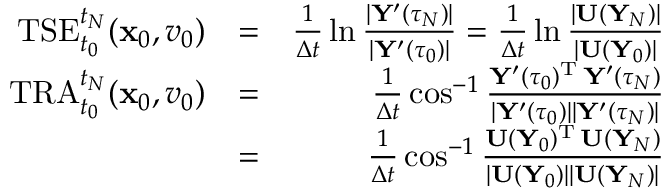<formula> <loc_0><loc_0><loc_500><loc_500>\begin{array} { r l r } { T S E _ { t _ { 0 } } ^ { t _ { N } } ( { \mathbf x } _ { 0 } , v _ { 0 } ) } & { = } & { \frac { 1 } { \Delta t } \ln \frac { | { \mathbf Y } ^ { \prime } ( \tau _ { N } ) | } { | { \mathbf Y } ^ { \prime } ( \tau _ { 0 } ) | } = \frac { 1 } { \Delta t } \ln \frac { | { \mathbf U } ( { \mathbf Y } _ { N } ) | } { | { \mathbf U } ( { \mathbf Y } _ { 0 } ) | } } \\ { T R A _ { t _ { 0 } } ^ { t _ { N } } ( { \mathbf x } _ { 0 } , v _ { 0 } ) } & { = } & { \frac { 1 } { \Delta t } \cos ^ { - 1 } \frac { { \mathbf Y } ^ { \prime } ( \tau _ { 0 } ) ^ { \mathrm T } \, { \mathbf Y } ^ { \prime } ( \tau _ { N } ) } { | { \mathbf Y } ^ { \prime } ( \tau _ { 0 } ) | | { \mathbf Y } ^ { \prime } ( \tau _ { N } ) | } } \\ & { = } & { \frac { 1 } { \Delta t } \cos ^ { - 1 } \frac { { \mathbf U } ( { \mathbf Y } _ { 0 } ) ^ { \mathrm T } \, { \mathbf U } ( { \mathbf Y } _ { N } ) } { | { \mathbf U } ( { \mathbf Y } _ { 0 } ) | | { \mathbf U } ( { \mathbf Y } _ { N } ) | } } \end{array}</formula> 